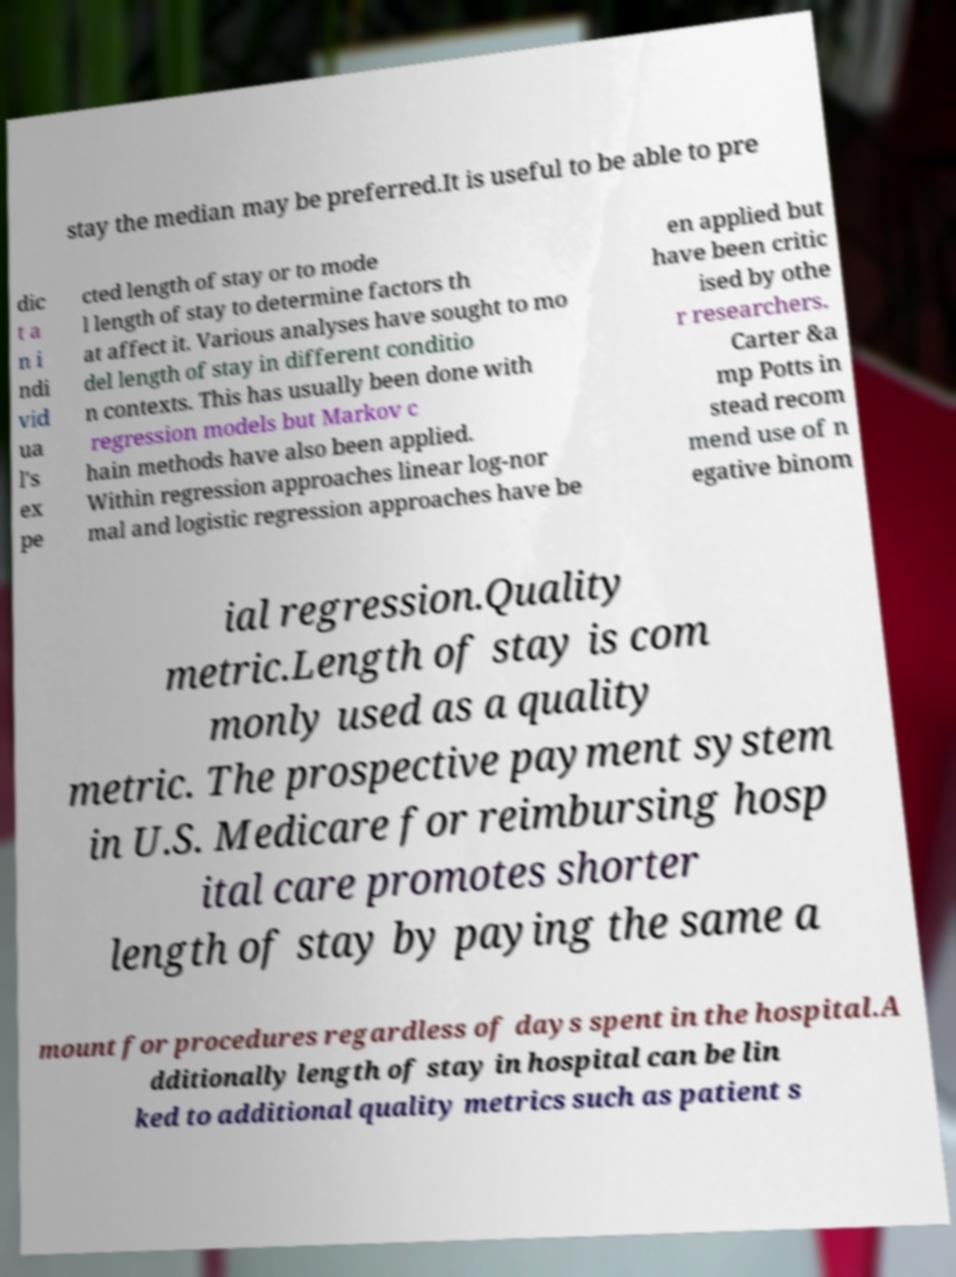I need the written content from this picture converted into text. Can you do that? stay the median may be preferred.It is useful to be able to pre dic t a n i ndi vid ua l's ex pe cted length of stay or to mode l length of stay to determine factors th at affect it. Various analyses have sought to mo del length of stay in different conditio n contexts. This has usually been done with regression models but Markov c hain methods have also been applied. Within regression approaches linear log-nor mal and logistic regression approaches have be en applied but have been critic ised by othe r researchers. Carter &a mp Potts in stead recom mend use of n egative binom ial regression.Quality metric.Length of stay is com monly used as a quality metric. The prospective payment system in U.S. Medicare for reimbursing hosp ital care promotes shorter length of stay by paying the same a mount for procedures regardless of days spent in the hospital.A dditionally length of stay in hospital can be lin ked to additional quality metrics such as patient s 